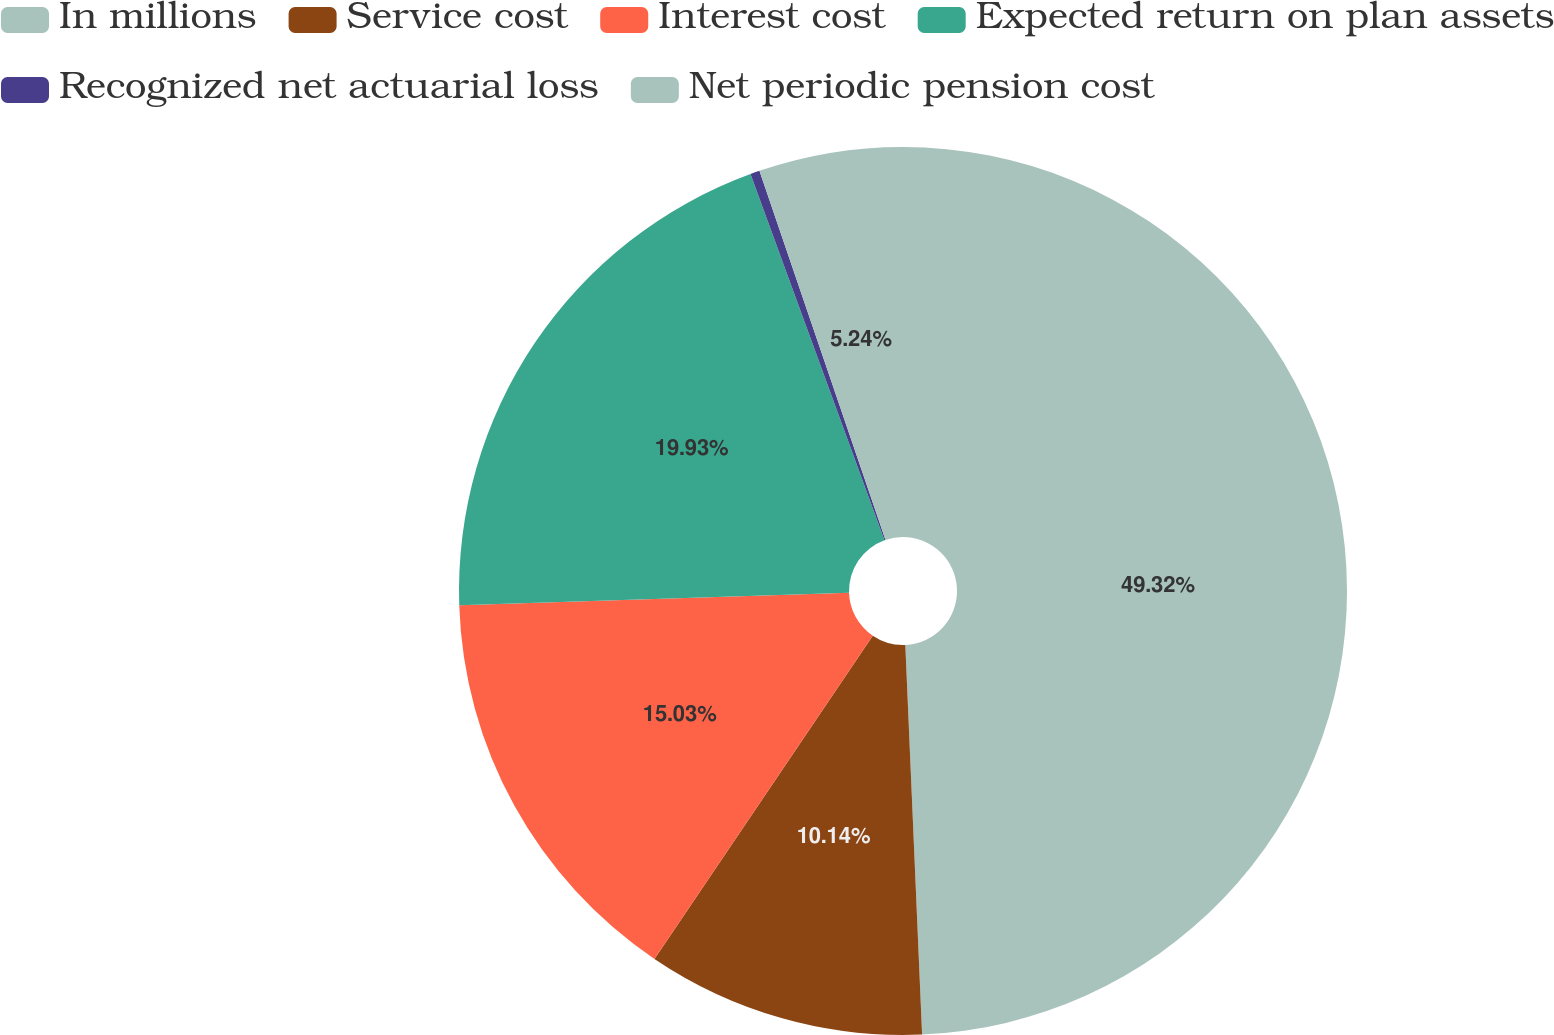<chart> <loc_0><loc_0><loc_500><loc_500><pie_chart><fcel>In millions<fcel>Service cost<fcel>Interest cost<fcel>Expected return on plan assets<fcel>Recognized net actuarial loss<fcel>Net periodic pension cost<nl><fcel>49.31%<fcel>10.14%<fcel>15.03%<fcel>19.93%<fcel>0.34%<fcel>5.24%<nl></chart> 